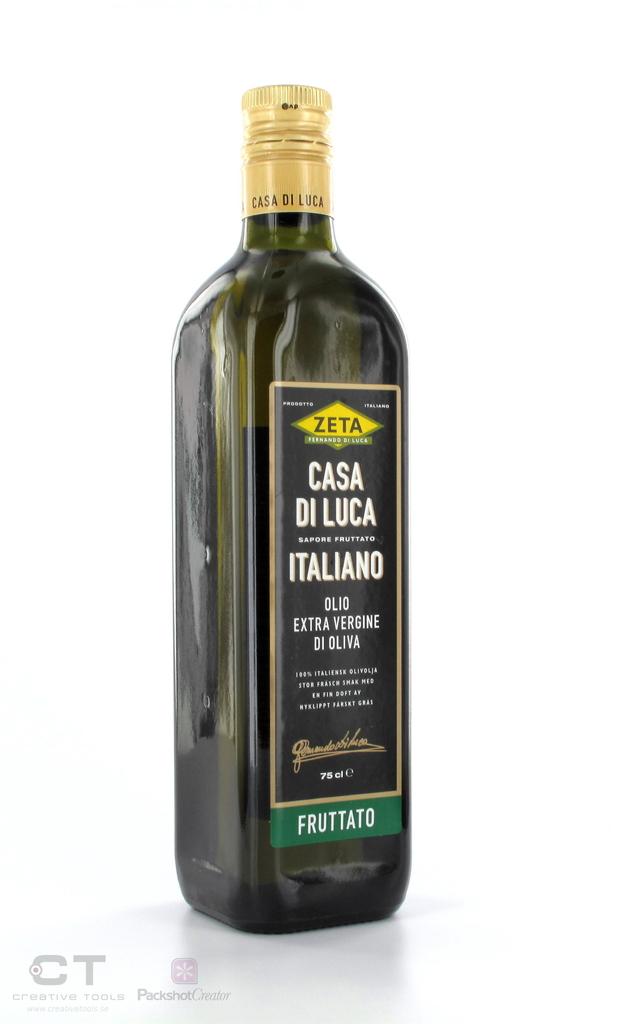What brand shows here?
Give a very brief answer. Zeta. 